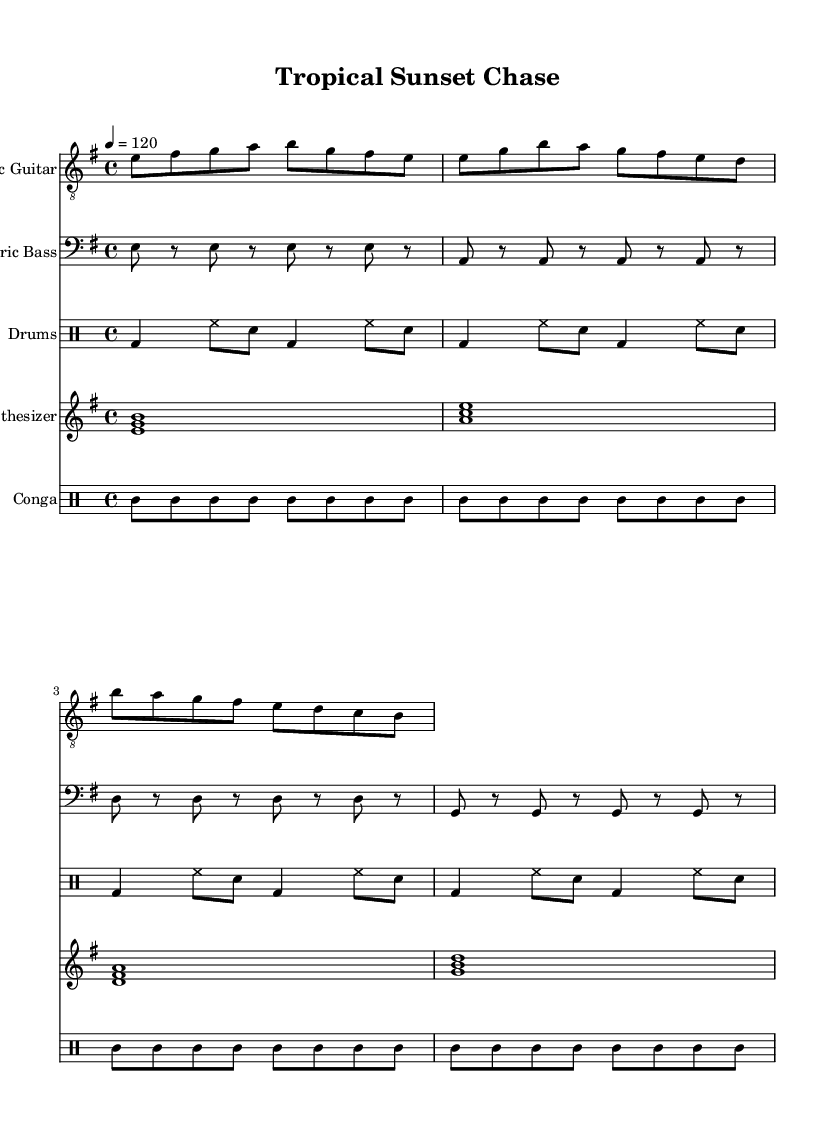what is the key signature of this music? The key signature is indicated at the beginning of the music sheet, displaying one sharp. This corresponds to the key of E minor, which is derived from G major and commonly found in funk music.
Answer: E minor what is the time signature of this piece? The time signature can be found at the beginning of the music, shown as 4/4. This means there are four beats in each measure, which is a standard time signature widely used in funk music.
Answer: 4/4 what is the tempo marking for this piece? The tempo marking is specified as 4 = 120, indicating that there are 120 beats per minute in the quarter note. This gives the piece a lively and upbeat feel characteristic of funk.
Answer: 120 how many measures are in the electric guitar part? By counting the number of vertical bar lines on the electric guitar staff, we can find the total number of measures. There are 4 measures visible in the electric guitar part.
Answer: 4 which instrument plays the conga part? The conga part is indicated with a specific drum staff labeled as "Conga." This clearly identifies which instrument is responsible for that part in the arrangement.
Answer: Conga what type of chords does the synthesizer part use? The synthesizer part features major chords built from the root, third, and fifth notes, which is a common practice in funk music to create a rich harmonic texture.
Answer: Major chords how many different instruments are featured in this music sheet? By examining the score, we can identify five distinct staves for the electric guitar, electric bass, drums, synthesizer, and conga, which indicates the number of different instruments involved.
Answer: Five 